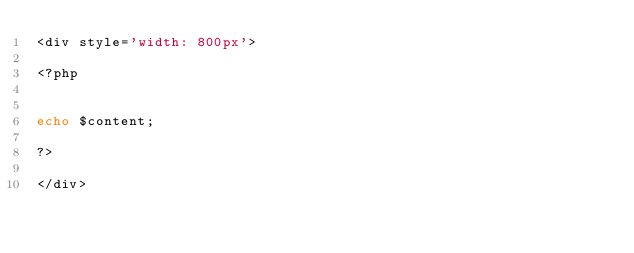Convert code to text. <code><loc_0><loc_0><loc_500><loc_500><_PHP_><div style='width: 800px'>

<?php


echo $content;

?>

</div></code> 